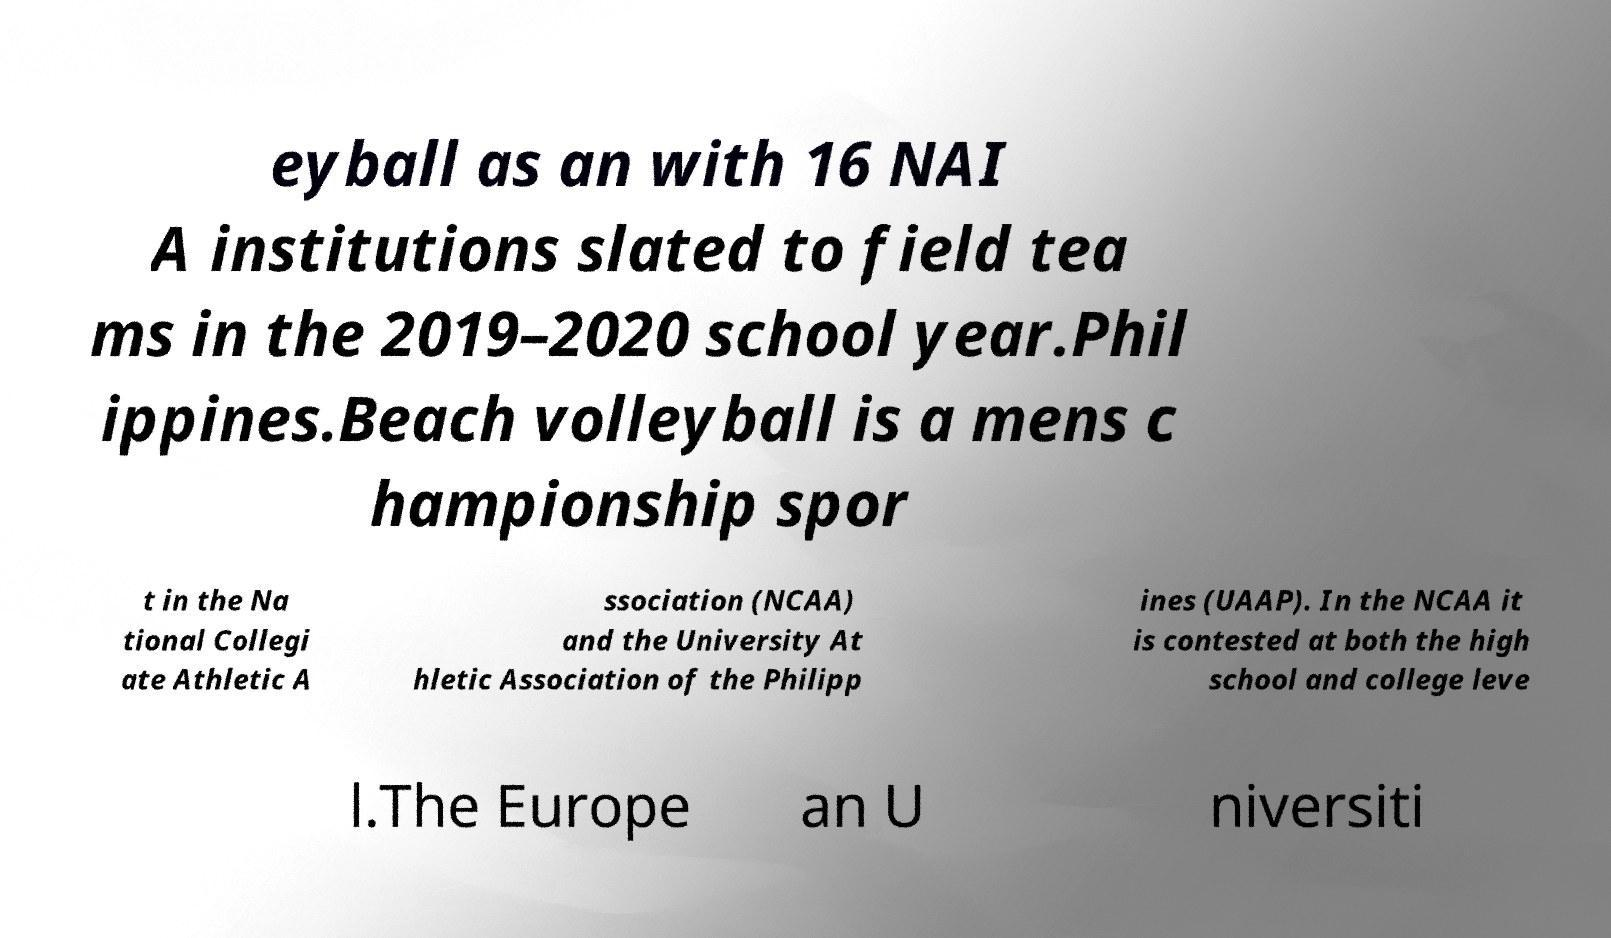Please identify and transcribe the text found in this image. eyball as an with 16 NAI A institutions slated to field tea ms in the 2019–2020 school year.Phil ippines.Beach volleyball is a mens c hampionship spor t in the Na tional Collegi ate Athletic A ssociation (NCAA) and the University At hletic Association of the Philipp ines (UAAP). In the NCAA it is contested at both the high school and college leve l.The Europe an U niversiti 